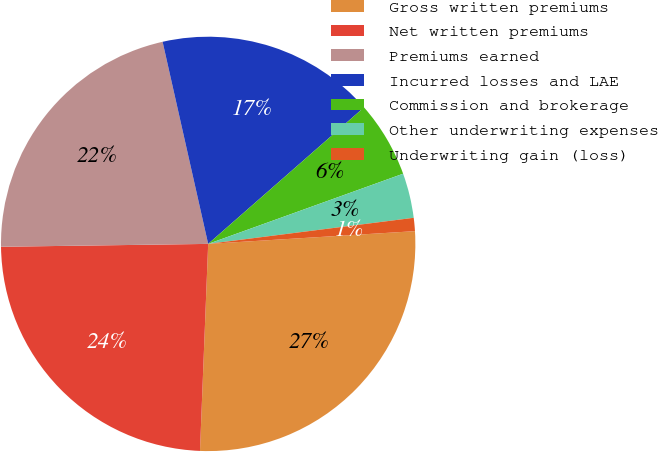<chart> <loc_0><loc_0><loc_500><loc_500><pie_chart><fcel>Gross written premiums<fcel>Net written premiums<fcel>Premiums earned<fcel>Incurred losses and LAE<fcel>Commission and brokerage<fcel>Other underwriting expenses<fcel>Underwriting gain (loss)<nl><fcel>26.61%<fcel>24.15%<fcel>21.69%<fcel>17.08%<fcel>5.95%<fcel>3.49%<fcel>1.03%<nl></chart> 